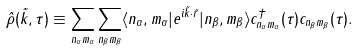<formula> <loc_0><loc_0><loc_500><loc_500>\hat { \rho } ( \vec { k } , \tau ) \equiv \sum _ { n _ { \alpha } m _ { \alpha } } \sum _ { n _ { \beta } m _ { \beta } } \langle n _ { \alpha } , m _ { \alpha } | e ^ { i \vec { k } \cdot \vec { r } } | n _ { \beta } , m _ { \beta } \rangle c ^ { \dagger } _ { n _ { \alpha } m _ { \alpha } } ( \tau ) c _ { n _ { \beta } m _ { \beta } } ( \tau ) .</formula> 